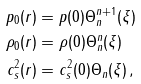<formula> <loc_0><loc_0><loc_500><loc_500>p _ { 0 } ( r ) & = p ( 0 ) \Theta _ { n } ^ { n + 1 } ( \xi ) \\ \rho _ { 0 } ( r ) & = \rho ( 0 ) \Theta _ { n } ^ { n } ( \xi ) \\ c _ { s } ^ { 2 } ( r ) & = c _ { s } ^ { 2 } ( 0 ) \Theta _ { n } ( \xi ) \, ,</formula> 